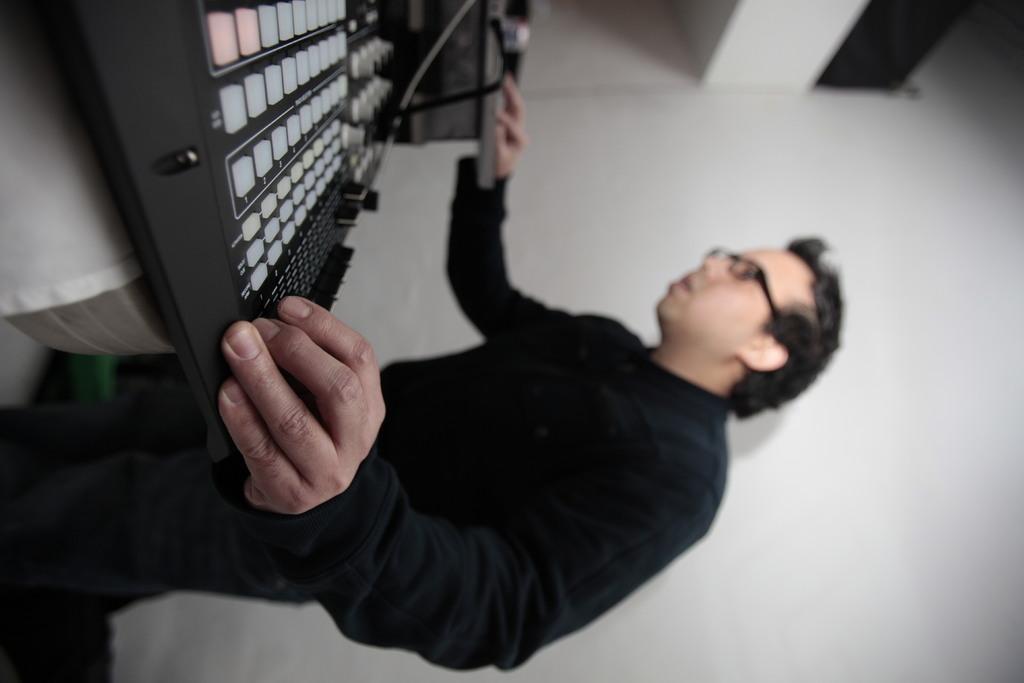In one or two sentences, can you explain what this image depicts? In this picture I can see a man standing, there are music systems on an object, and in the background there is a wall. 